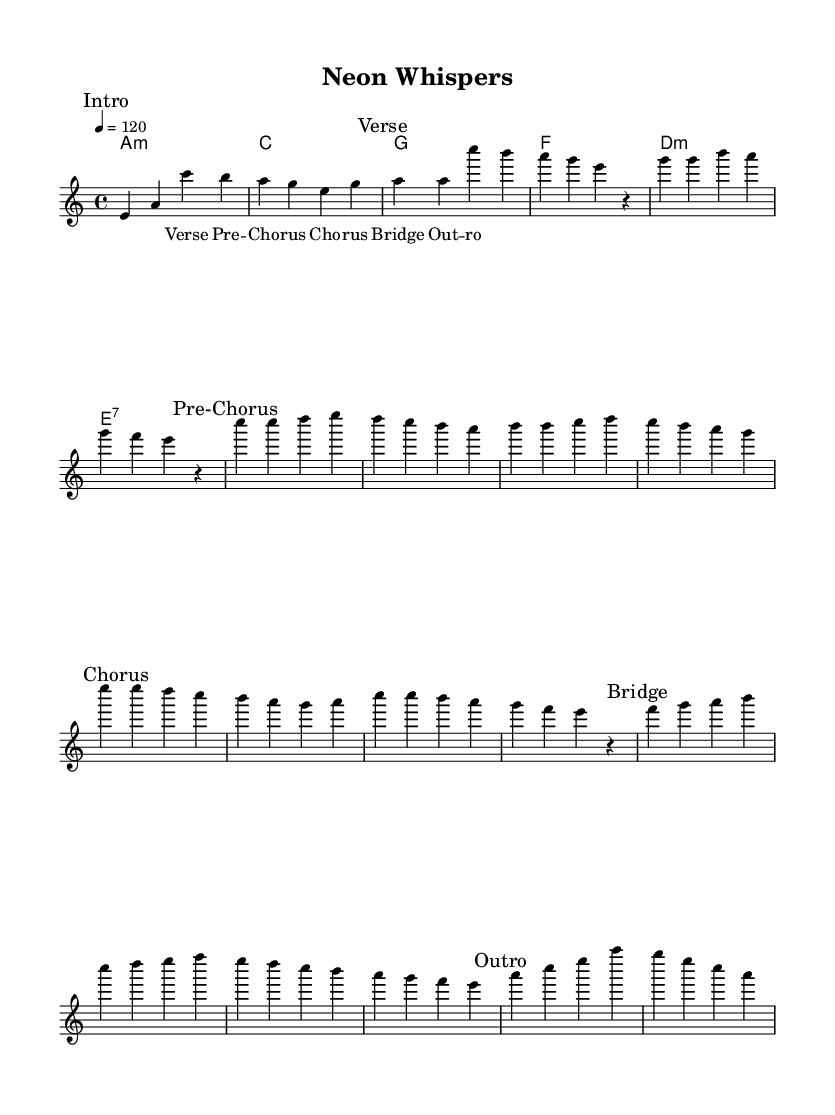What is the key signature of this music? The key signature is A minor, which has no sharps or flats, evident from the initial part of the global definition.
Answer: A minor What is the time signature of this composition? The time signature is 4/4, indicated in the global settings of the music sheet. This means there are four beats in each measure, with a quarter note getting one beat.
Answer: 4/4 What is the tempo marking for this piece? The tempo marking indicated is quarter note equals 120, which is shown in the global section. This means the piece should be played at a speed of 120 quarter notes per minute.
Answer: 120 What is the first note of the melody? The first note in the melody section is E, as seen in the sequence where the melody starts.
Answer: E How many distinct sections are present in the structure of this piece? There are five distinct sections in the piece: Intro, Verse, Pre-Chorus, Chorus, and Bridge, as labeled in the melody. This can be counted by identifying the marks in the melody.
Answer: 5 Which chord is played during the Outro section? The chord played during the Outro section is A minor, as it is listed in the harmonies corresponding to the last part of the melody.
Answer: A minor What type of vocal processing might complement the futuristic electronic elements in this piece? Given the pop style with electronic influences, vocal processing like pitch-shifting or heavy reverb could enhance the futuristic sound, leveraging the pop production techniques. This is inferred from the context of unconventional vocal treatments common in the genre.
Answer: Pitch-shifting or heavy reverb 